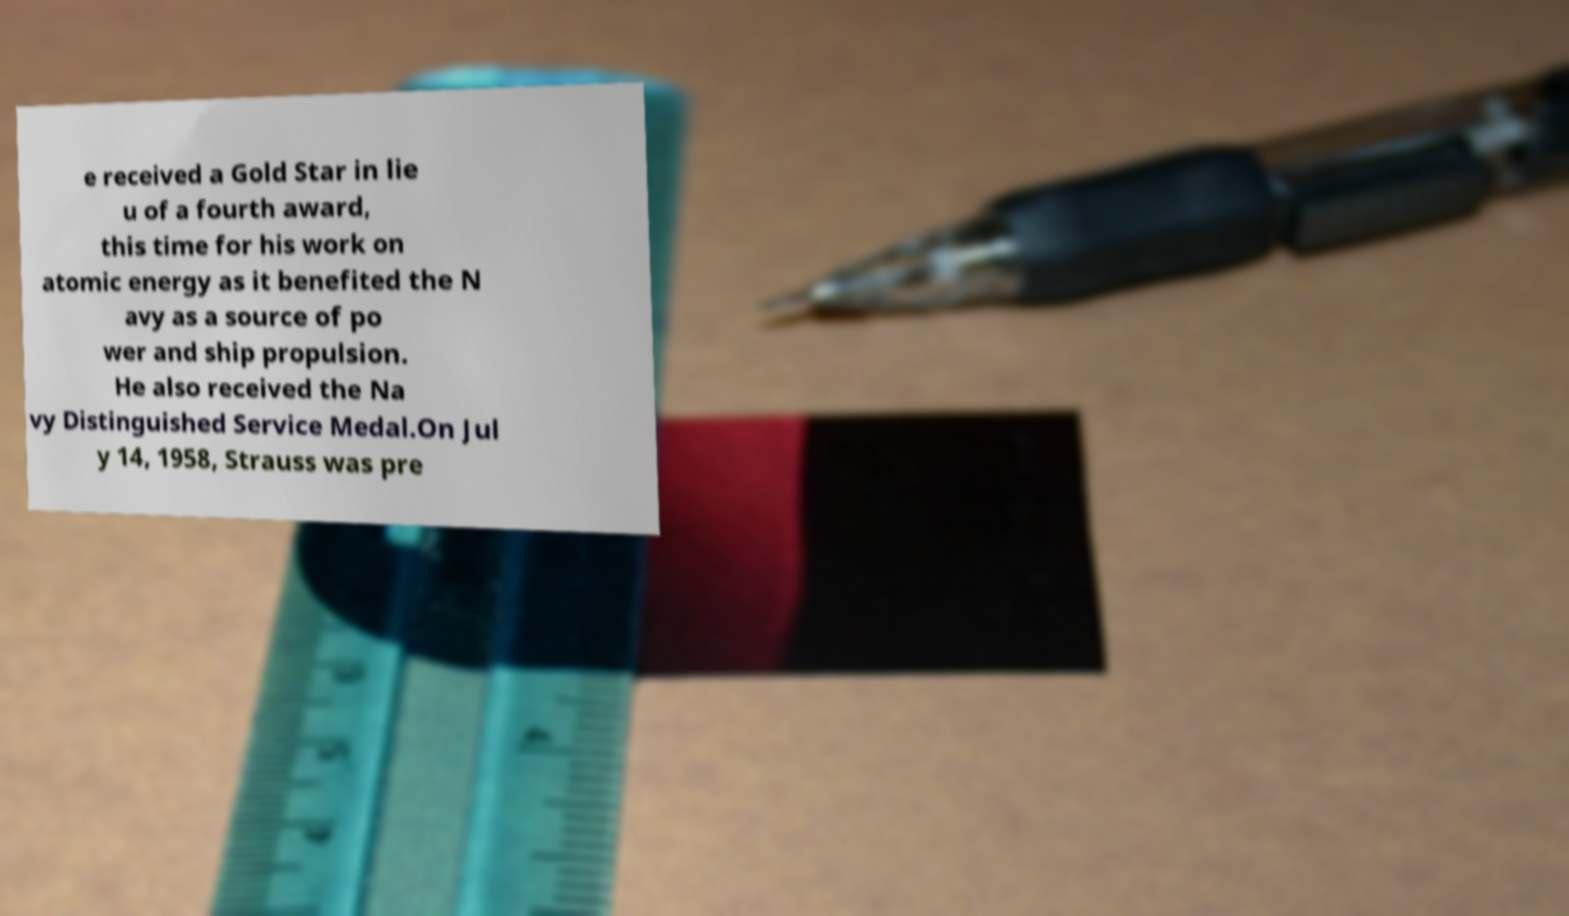Can you accurately transcribe the text from the provided image for me? e received a Gold Star in lie u of a fourth award, this time for his work on atomic energy as it benefited the N avy as a source of po wer and ship propulsion. He also received the Na vy Distinguished Service Medal.On Jul y 14, 1958, Strauss was pre 